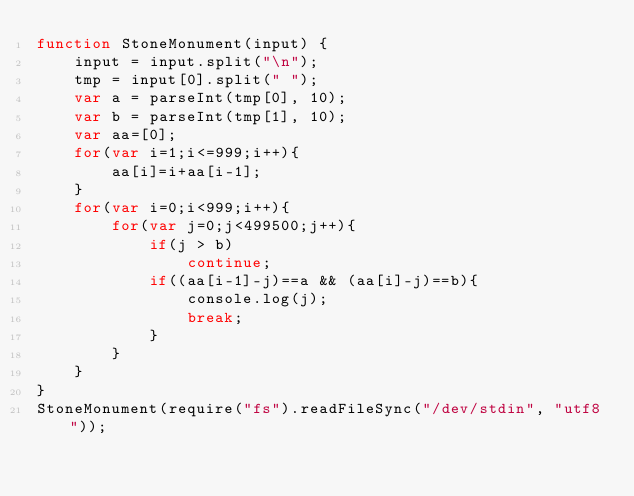Convert code to text. <code><loc_0><loc_0><loc_500><loc_500><_JavaScript_>function StoneMonument(input) {
    input = input.split("\n");
    tmp = input[0].split(" ");
    var a = parseInt(tmp[0], 10);
    var b = parseInt(tmp[1], 10);
    var aa=[0];
    for(var i=1;i<=999;i++){
        aa[i]=i+aa[i-1];
    }
    for(var i=0;i<999;i++){
        for(var j=0;j<499500;j++){
            if(j > b)
                continue;
            if((aa[i-1]-j)==a && (aa[i]-j)==b){
                console.log(j);
                break;
            }
        }
    }
}
StoneMonument(require("fs").readFileSync("/dev/stdin", "utf8"));</code> 